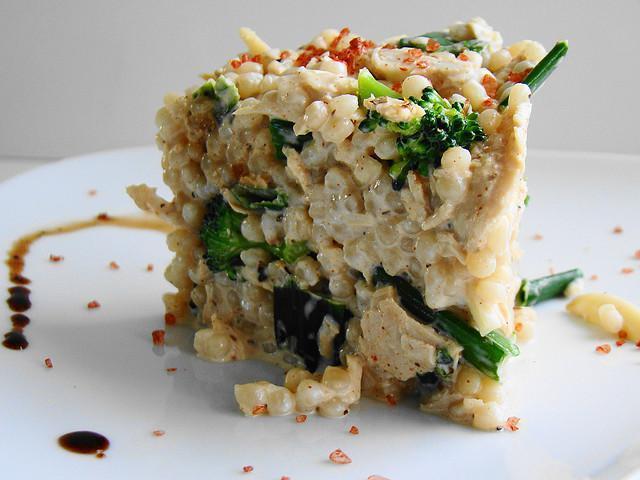How many broccolis are there?
Give a very brief answer. 2. 